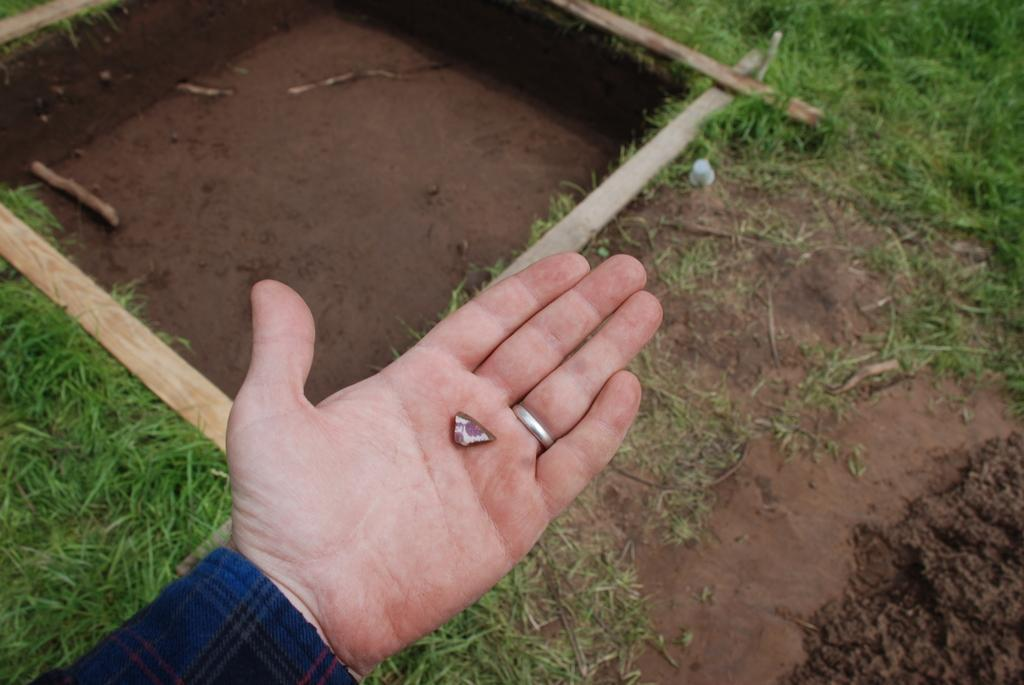What part of a person can be seen in the image? There is a hand of a person in the image. Where is the hand located in the image? The hand is in the front of the image. What type of surface is visible on the ground in the image? There is grass on the ground in the image. How many cannons are present in the image? There are no cannons present in the image. What type of spider web can be seen in the image? There is no spider web, or cobweb, present in the image. 